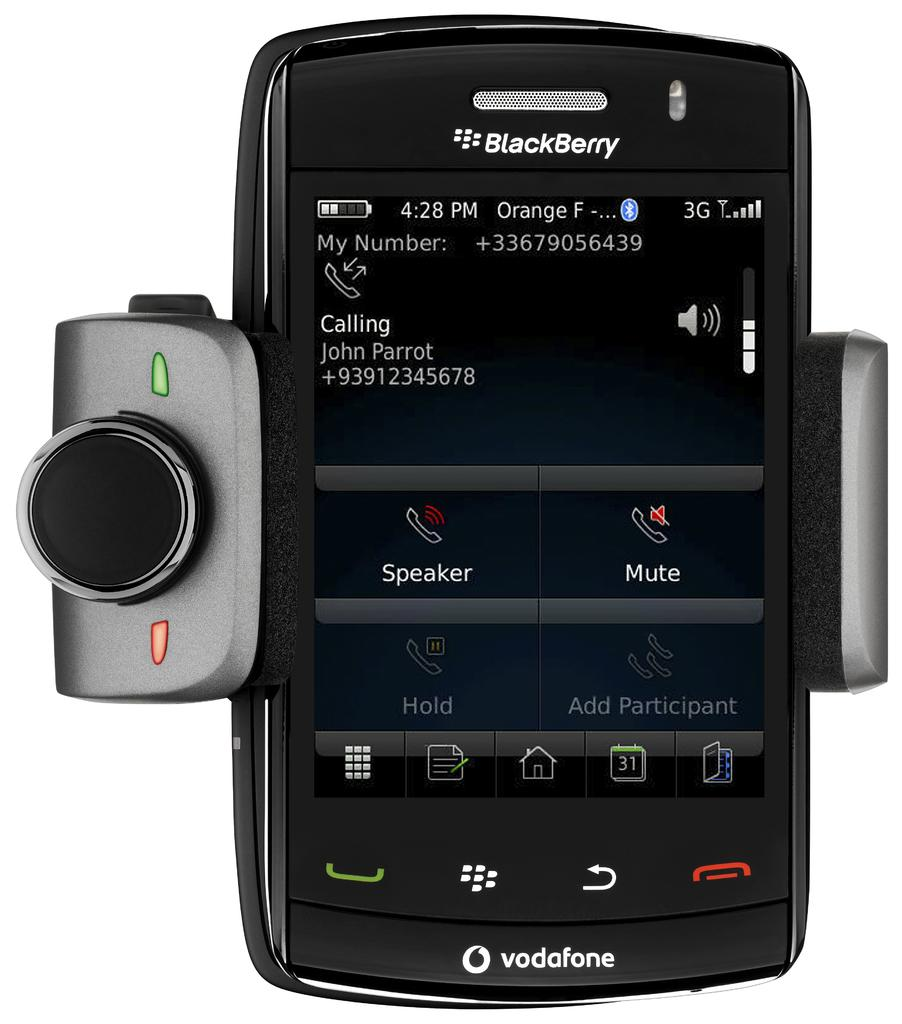<image>
Relay a brief, clear account of the picture shown. a BlackBerry phone by vodafone with an add on camera 